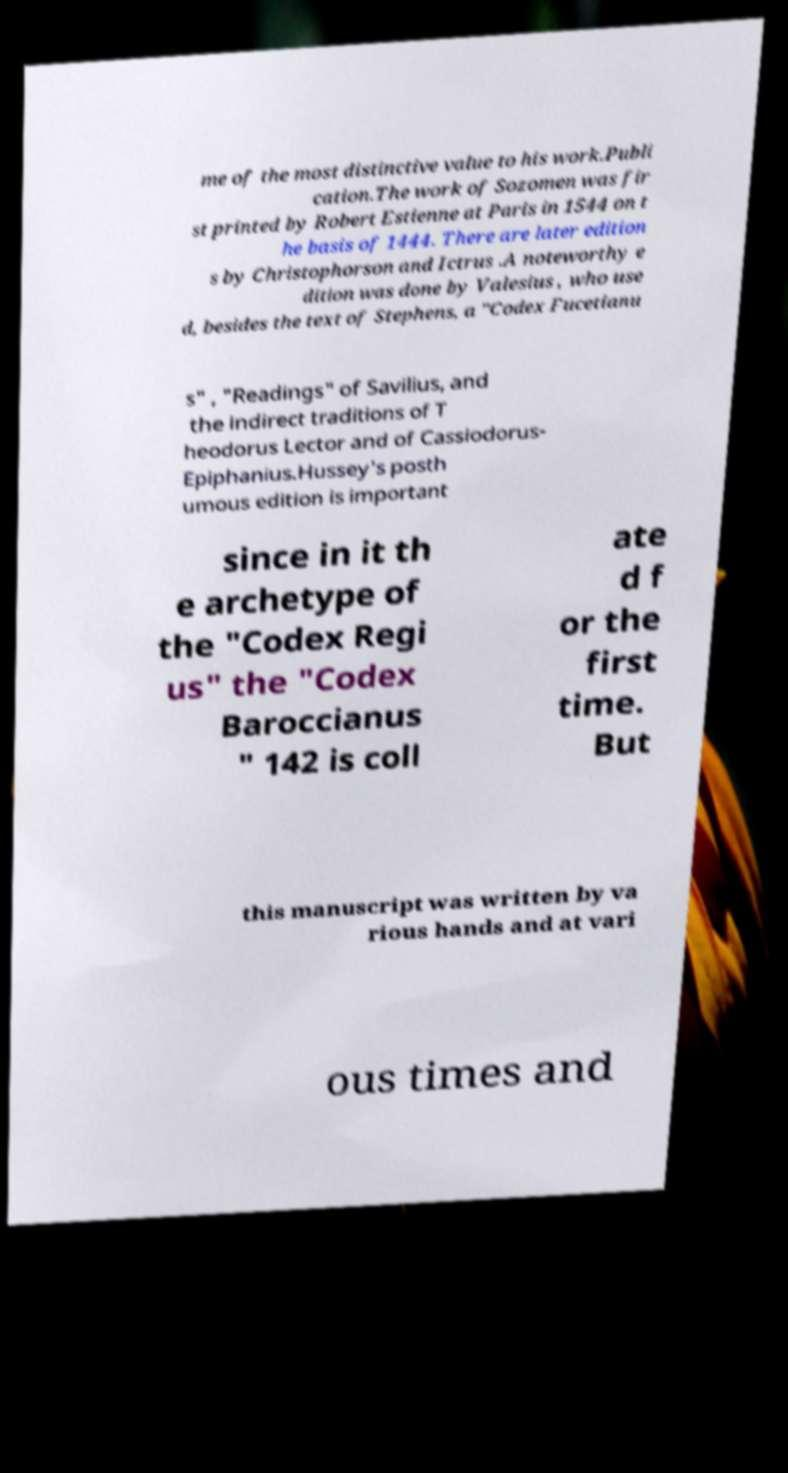Can you accurately transcribe the text from the provided image for me? me of the most distinctive value to his work.Publi cation.The work of Sozomen was fir st printed by Robert Estienne at Paris in 1544 on t he basis of 1444. There are later edition s by Christophorson and Ictrus .A noteworthy e dition was done by Valesius , who use d, besides the text of Stephens, a "Codex Fucetianu s" , "Readings" of Savilius, and the indirect traditions of T heodorus Lector and of Cassiodorus- Epiphanius.Hussey's posth umous edition is important since in it th e archetype of the "Codex Regi us" the "Codex Baroccianus " 142 is coll ate d f or the first time. But this manuscript was written by va rious hands and at vari ous times and 